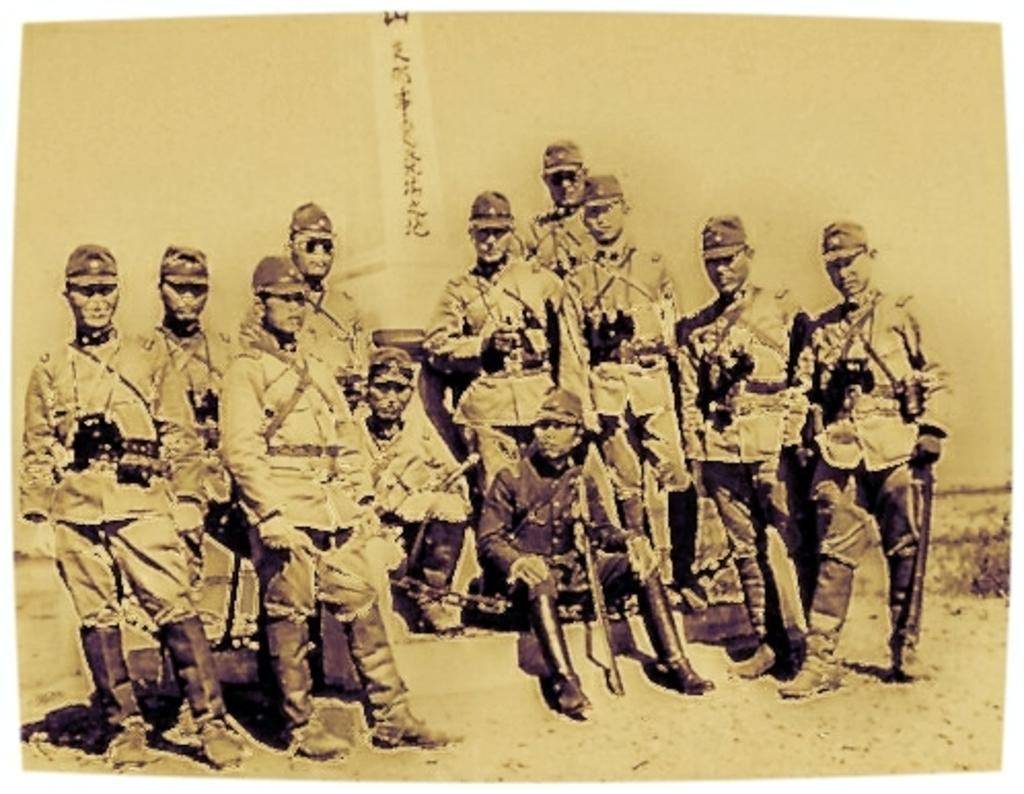What is the main subject of the image? The main subject of the image is a photograph of a group of people. Where are the people in the photograph located? The people are standing on the ground. Can you describe the two men in the image? There are two men sitting in the image. What else can be seen in the background of the photograph? There is a flag and the sky visible in the image. What type of robin can be seen perched on the flag in the image? There is no robin present in the image; it only features a photograph of a group of people, two men sitting, and a flag. 